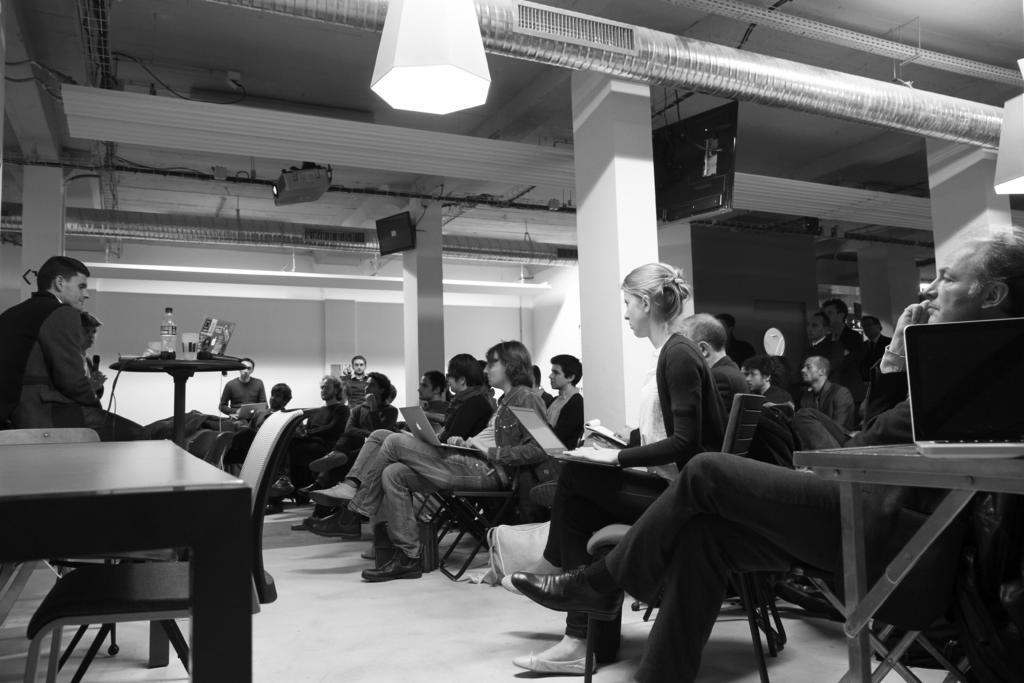Describe this image in one or two sentences. As we can see in the image there is a white color wall, projector, few people sitting on chairs and a laptop, table and there is a glass and bottle. 